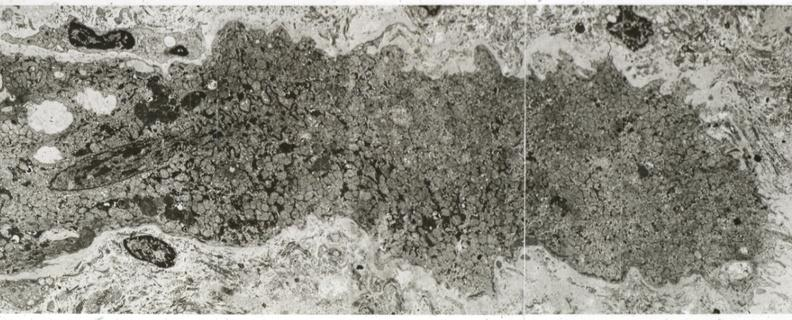s peritoneum present?
Answer the question using a single word or phrase. No 